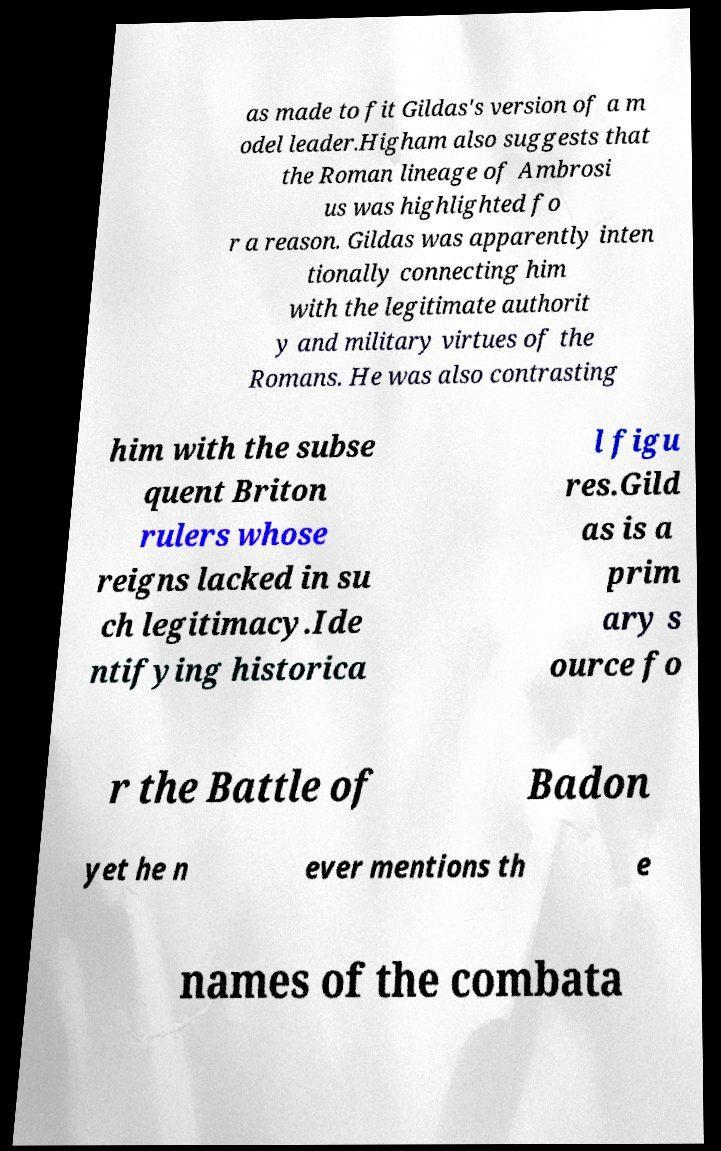For documentation purposes, I need the text within this image transcribed. Could you provide that? as made to fit Gildas's version of a m odel leader.Higham also suggests that the Roman lineage of Ambrosi us was highlighted fo r a reason. Gildas was apparently inten tionally connecting him with the legitimate authorit y and military virtues of the Romans. He was also contrasting him with the subse quent Briton rulers whose reigns lacked in su ch legitimacy.Ide ntifying historica l figu res.Gild as is a prim ary s ource fo r the Battle of Badon yet he n ever mentions th e names of the combata 